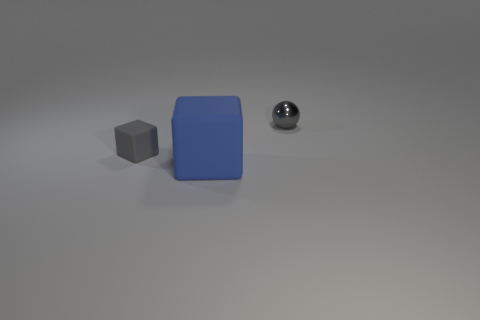Add 2 small rubber blocks. How many objects exist? 5 Subtract all blue cubes. How many cubes are left? 1 Add 1 blue matte blocks. How many blue matte blocks exist? 2 Subtract 0 red cubes. How many objects are left? 3 Subtract all balls. How many objects are left? 2 Subtract all red cubes. Subtract all yellow cylinders. How many cubes are left? 2 Subtract all cyan balls. How many blue cubes are left? 1 Subtract all matte blocks. Subtract all tiny gray shiny objects. How many objects are left? 0 Add 1 large blue blocks. How many large blue blocks are left? 2 